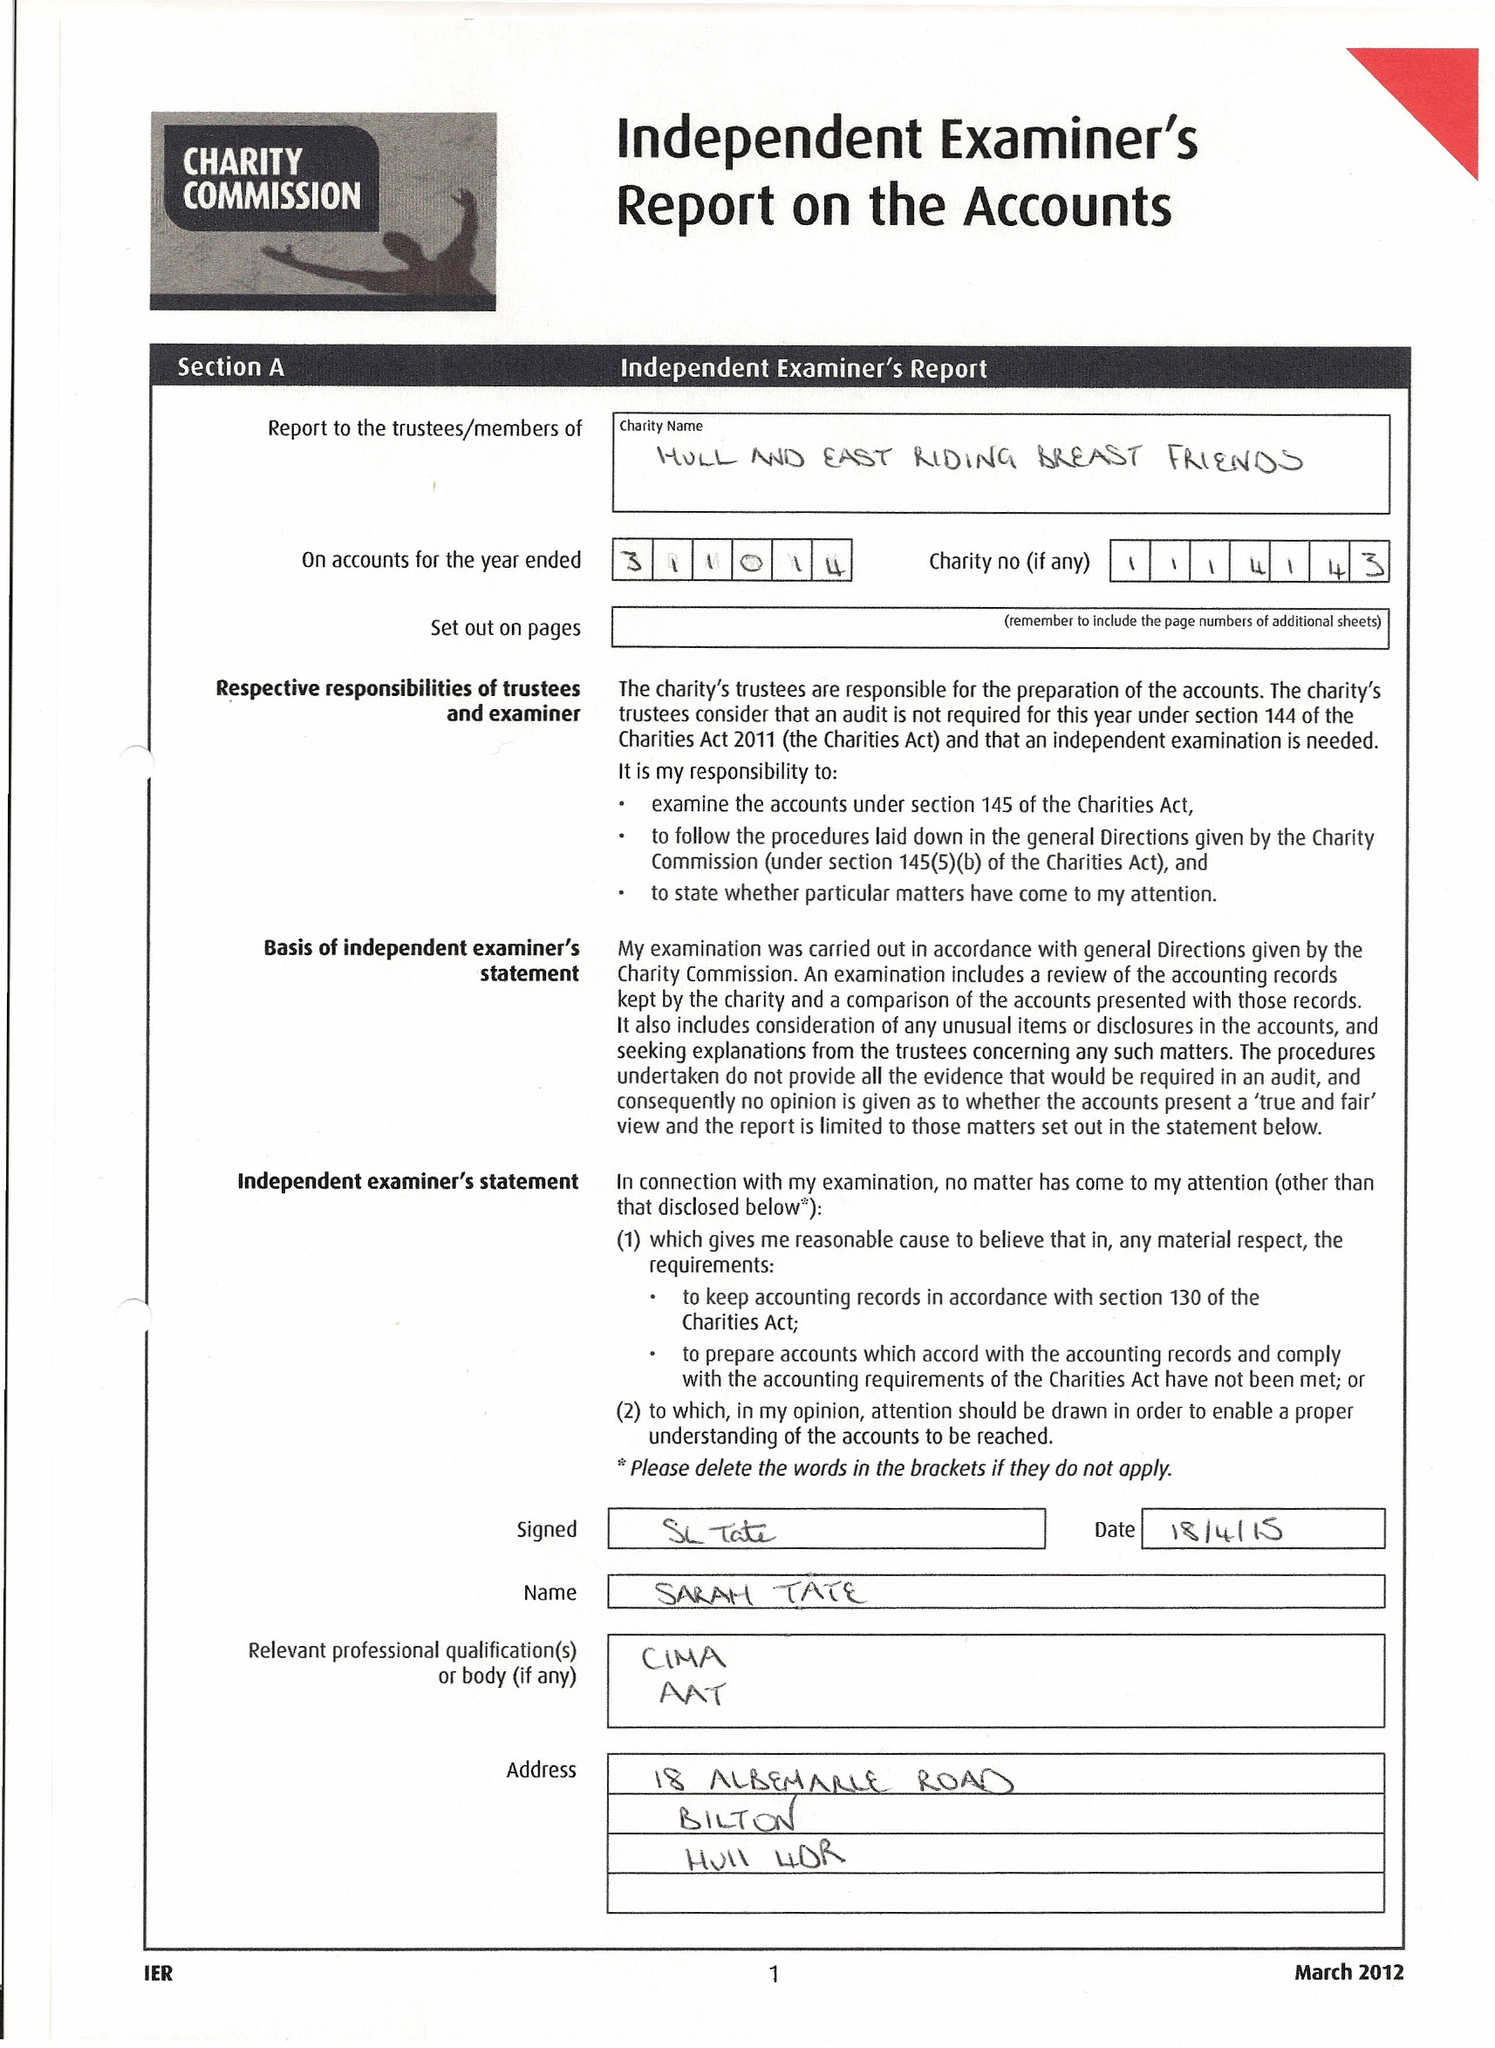What is the value for the address__post_town?
Answer the question using a single word or phrase. HULL 